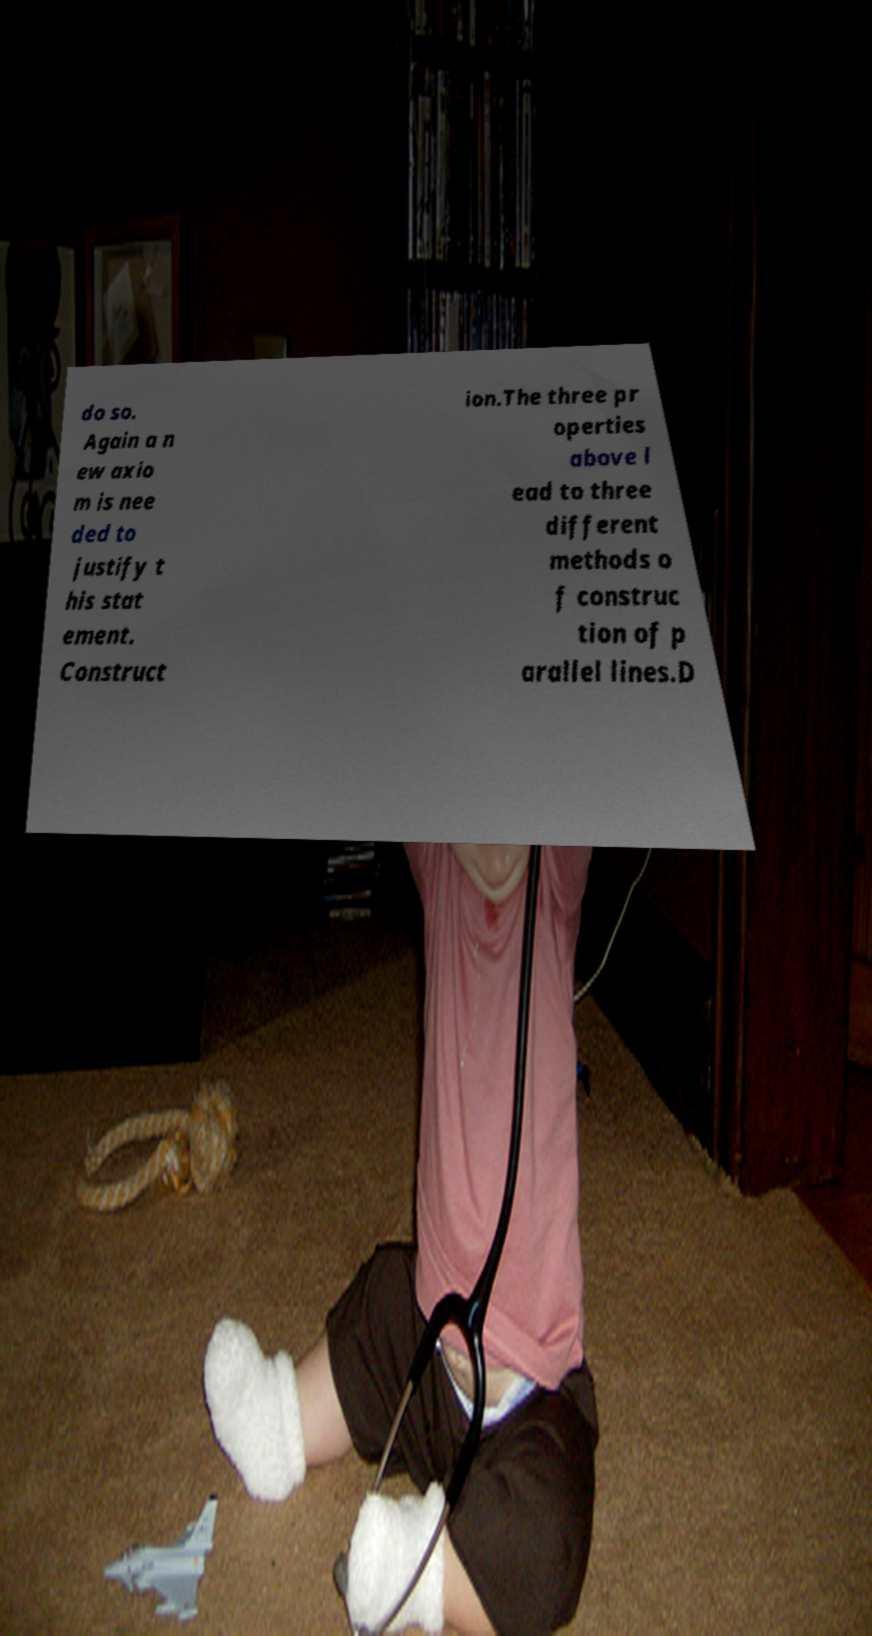Could you assist in decoding the text presented in this image and type it out clearly? do so. Again a n ew axio m is nee ded to justify t his stat ement. Construct ion.The three pr operties above l ead to three different methods o f construc tion of p arallel lines.D 